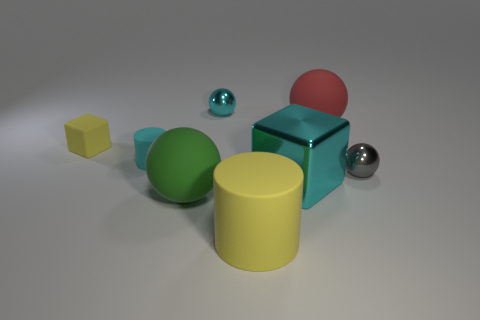Is the color of the big matte cylinder the same as the tiny rubber cube?
Offer a terse response. Yes. Do the ball that is in front of the gray metal sphere and the tiny rubber cylinder have the same size?
Ensure brevity in your answer.  No. Are there the same number of big cyan shiny blocks to the right of the large cyan cube and large cyan shiny objects that are in front of the red rubber thing?
Your answer should be compact. No. How many other things are made of the same material as the big block?
Provide a short and direct response. 2. What number of tiny things are either yellow rubber objects or cyan shiny cylinders?
Provide a short and direct response. 1. Are there the same number of gray metallic balls that are behind the tiny rubber cylinder and red metal spheres?
Your answer should be very brief. Yes. Are there any blocks that are in front of the tiny gray metal ball that is on the right side of the red sphere?
Your answer should be compact. Yes. How many other objects are there of the same color as the large matte cylinder?
Make the answer very short. 1. What is the color of the big matte cylinder?
Provide a succinct answer. Yellow. How big is the cyan object that is both to the left of the yellow cylinder and in front of the tiny yellow rubber object?
Your response must be concise. Small. 